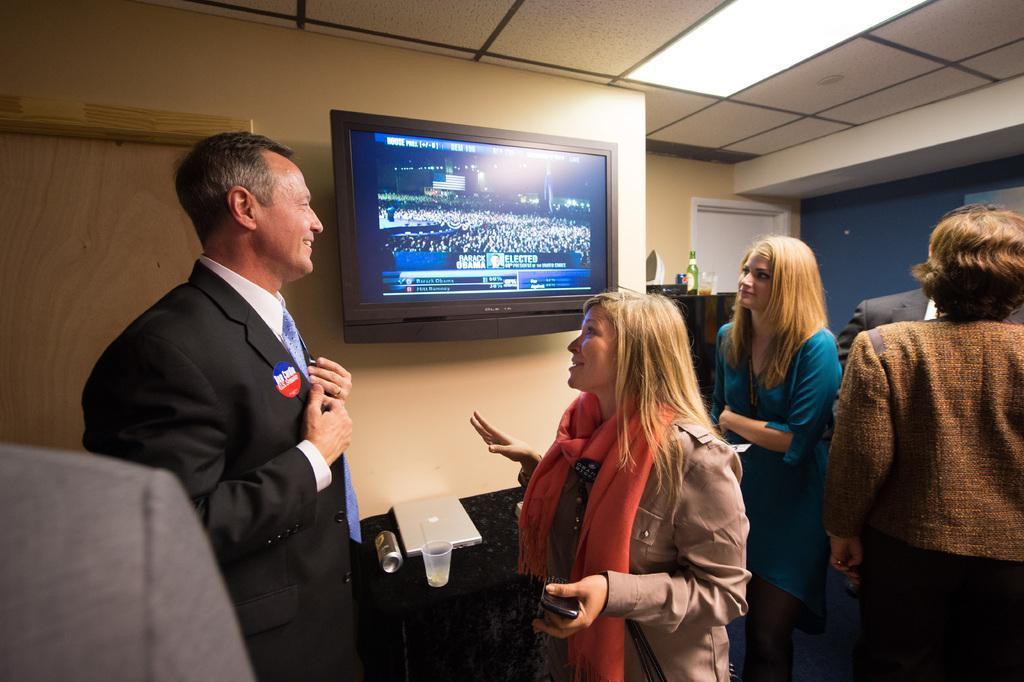Describe this image in one or two sentences. In this image, I can see a group of people standing. This is a television, which is attached to the wall. This looks like a wooden door. I think this is a table covered with a cloth. I can see a laptop, glass and tin are placed on the table. I can see few objects placed here. This is the ceiling light which is attached to the roof. 